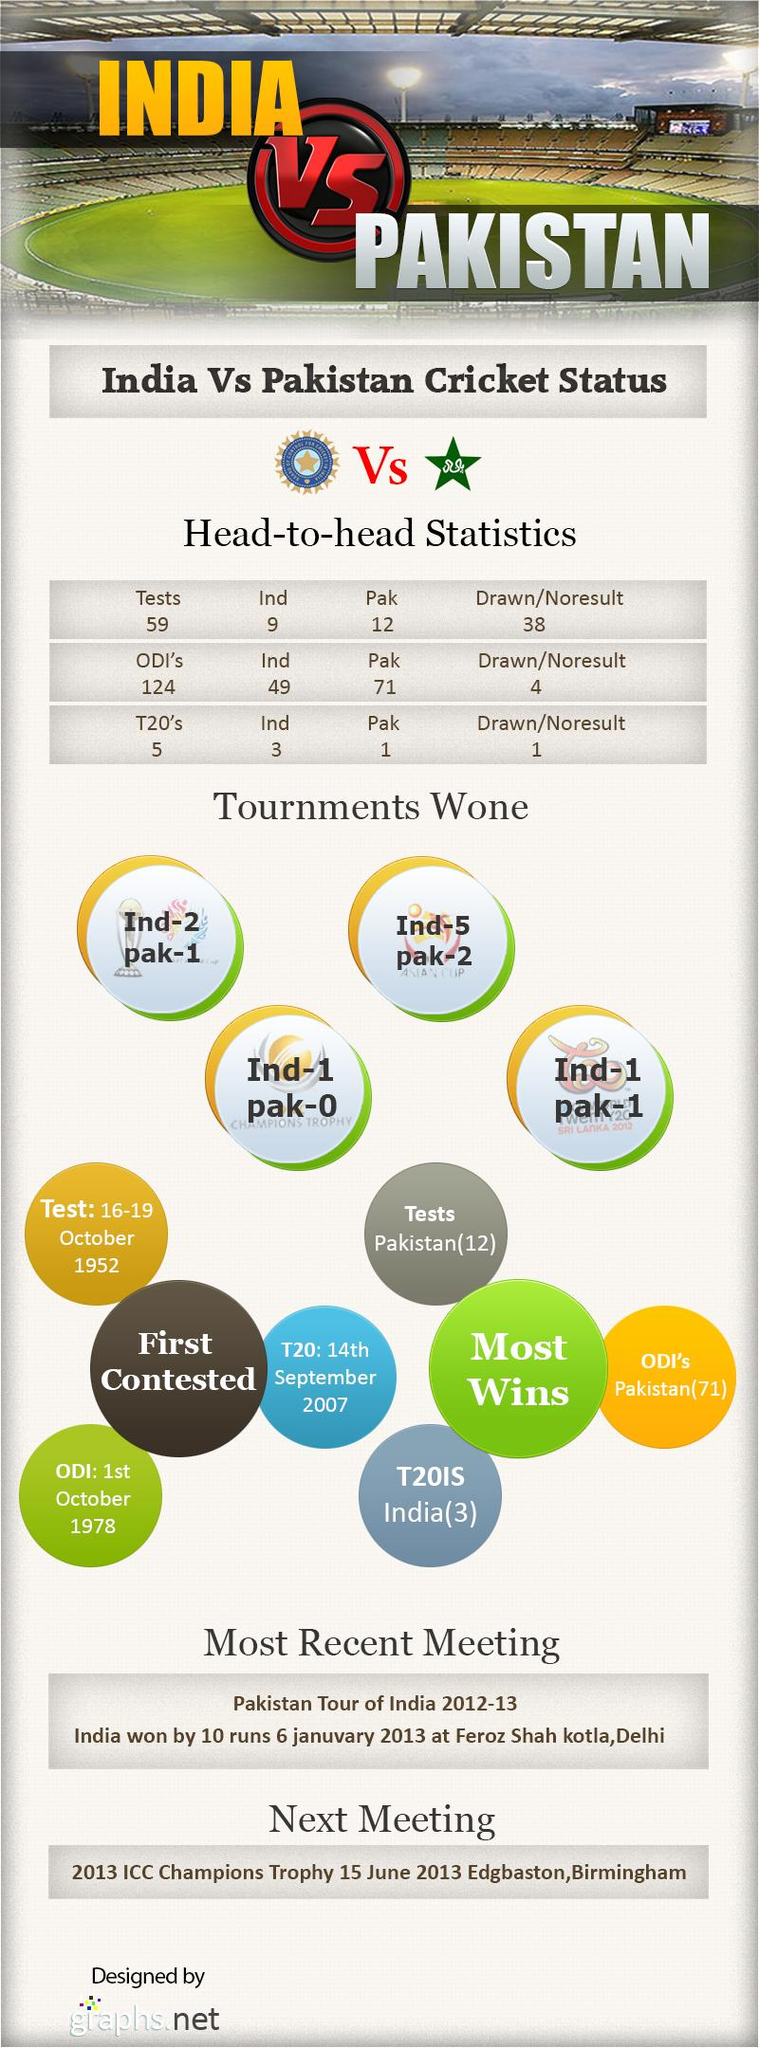Outline some significant characteristics in this image. India won 2 out of the 3 matches played against Pakistan in the ICC World Twenty20 2012. India won the Asian Cup 5 times. Pakistan has won one World Cup. There are multiple formats of Cricket, including Test matches, One Day Internationals (ODIs), and Twenty20 (T20) matches. There are three formats of cricket. 